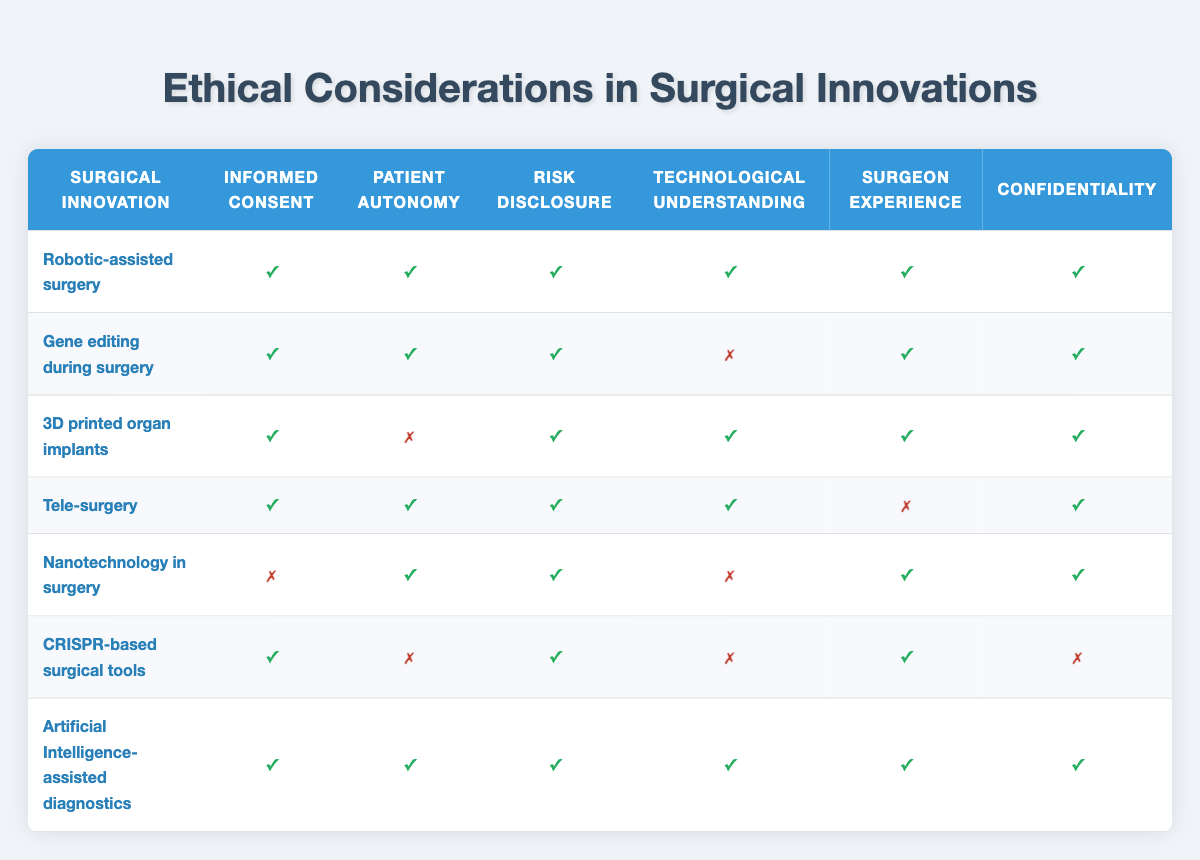What is the surgical innovation with the highest level of informed consent? Robotic-assisted surgery, gene editing during surgery, 3D printed organ implants, tele-surgery, CRISPR-based surgical tools, and AI-assisted diagnostics all have informed consent marked as true. However, robotic-assisted surgery is the first listed, so it can be considered the highest level of informed consent.
Answer: Robotic-assisted surgery How many surgical innovations have patient autonomy marked as true? By reviewing the table, robotic-assisted surgery, gene editing during surgery, tele-surgery, and AI-assisted diagnostics have patient autonomy marked as true, which totals four.
Answer: 4 Is confidentiality a concern in CRISPR-based surgical tools? The table indicates that confidentiality for CRISPR-based surgical tools is marked as false. This indicates a concern regarding confidentiality in this innovation.
Answer: Yes Which surgical innovation lacks both technological understanding and informed consent? The table shows that nanotechnology in surgery has informed consent marked as false, and it also has technological understanding marked as false, making it the surgical innovation that lacks both.
Answer: Nanotechnology in surgery What are the surgical innovations that fulfill all six ethical considerations? By examining the table, the only surgical innovation that fulfills all six ethical considerations is Artificial Intelligence-assisted diagnostics, as it has true for all listed categories.
Answer: Artificial Intelligence-assisted diagnostics Which surgical innovation demonstrates a conflict between patient autonomy and informed consent? The table shows both CRISPR-based surgical tools and 3D printed organ implants where patient autonomy is labeled as false while informed consent is true, indicating a conflict in these innovations.
Answer: CRISPR-based surgical tools and 3D printed organ implants How does the ratio of innovations with risk disclosure to those without it compare? Only nanotechnology in surgery lacks risk disclosure, while all others have it marked as true. Therefore, there's a ratio of 6:1, indicating that for every one innovation without risk disclosure, there are six that have it.
Answer: 6:1 What are the implications if a surgical innovation has high surgeon experience but low patient autonomy? The implications suggest that while the surgeon may be well-qualified, the lack of patient autonomy could lead to ethical concerns about consent and the patient's role in decision-making. This could lead to potential disputes or dissatisfaction from patients regarding their involvement in their treatment.
Answer: Ethical concerns arise How many surgical innovations listed have all ethical considerations marked as true? Upon reviewing the table, only one surgical innovation—Artificial Intelligence-assisted diagnostics—has all columns marked as true for all ethical considerations.
Answer: 1 What can be concluded about the overall trend in ethical considerations for newer surgical innovations? The overall trend suggests that while many newer surgical innovations are focusing on obtaining informed consent and disclosing risks, there are critical areas lacking, such as patient autonomy, technological understanding, and confidentiality, that need attention in future developments.
Answer: Critical areas lacking attention 